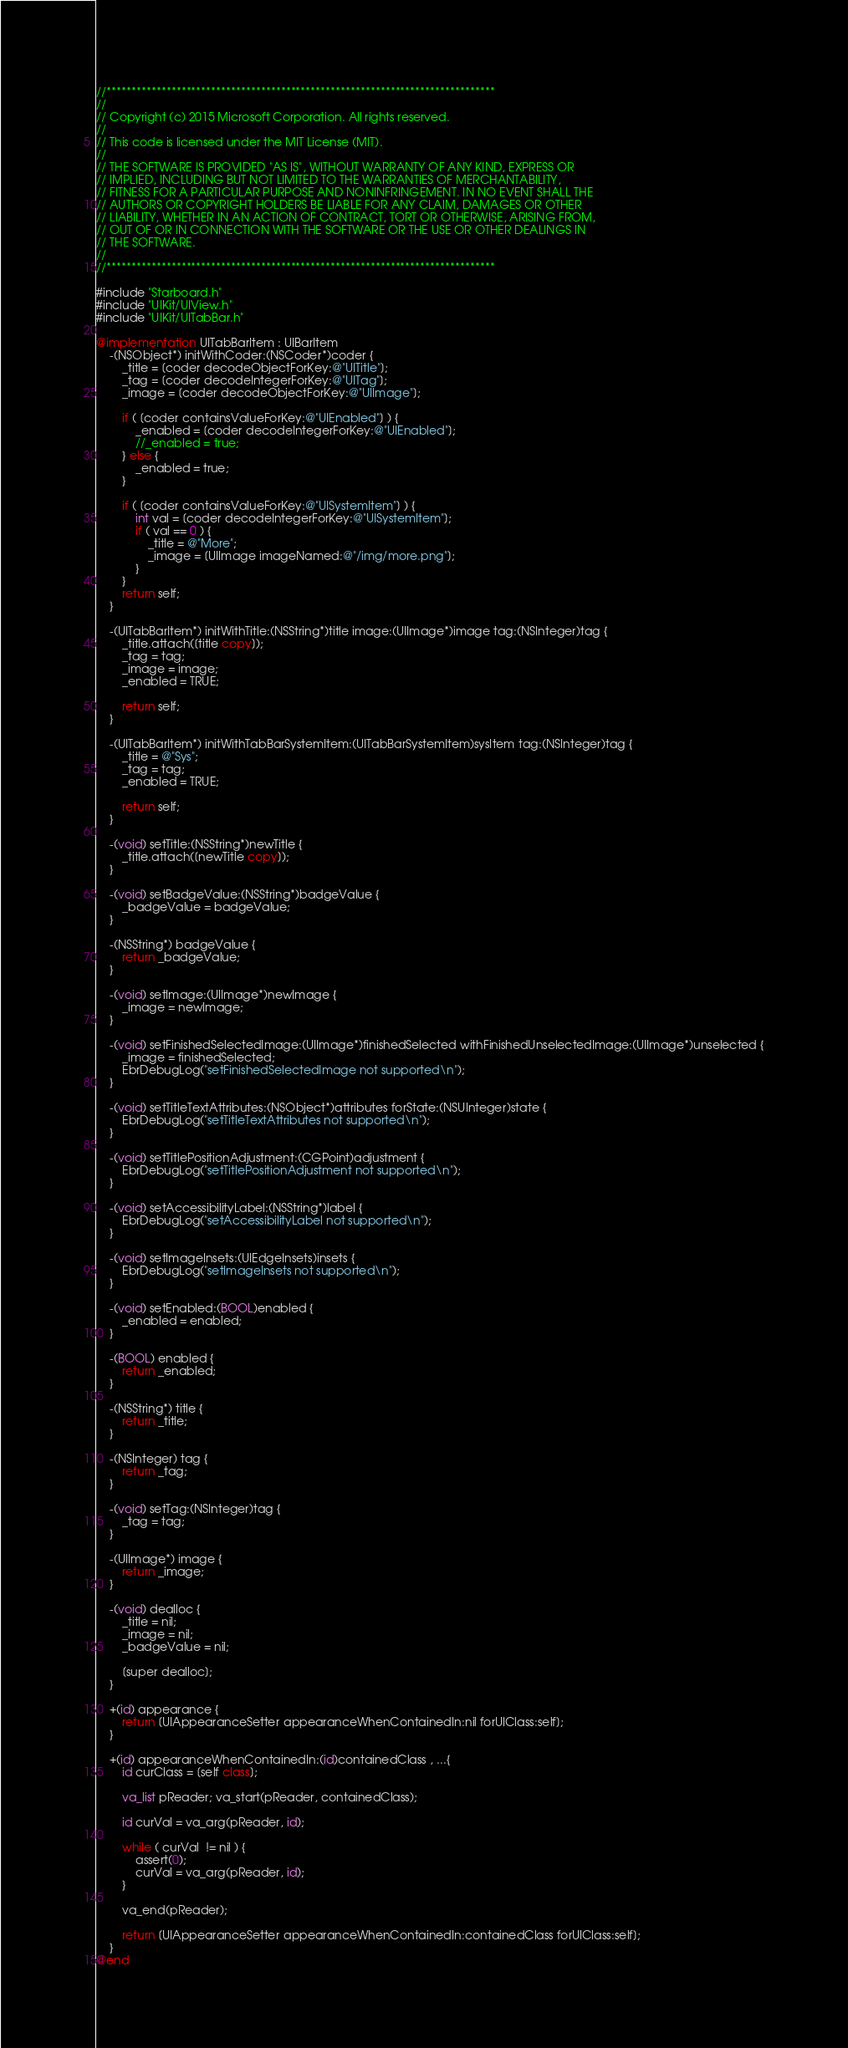<code> <loc_0><loc_0><loc_500><loc_500><_ObjectiveC_>//******************************************************************************
//
// Copyright (c) 2015 Microsoft Corporation. All rights reserved.
//
// This code is licensed under the MIT License (MIT).
//
// THE SOFTWARE IS PROVIDED "AS IS", WITHOUT WARRANTY OF ANY KIND, EXPRESS OR
// IMPLIED, INCLUDING BUT NOT LIMITED TO THE WARRANTIES OF MERCHANTABILITY,
// FITNESS FOR A PARTICULAR PURPOSE AND NONINFRINGEMENT. IN NO EVENT SHALL THE
// AUTHORS OR COPYRIGHT HOLDERS BE LIABLE FOR ANY CLAIM, DAMAGES OR OTHER
// LIABILITY, WHETHER IN AN ACTION OF CONTRACT, TORT OR OTHERWISE, ARISING FROM,
// OUT OF OR IN CONNECTION WITH THE SOFTWARE OR THE USE OR OTHER DEALINGS IN
// THE SOFTWARE.
//
//******************************************************************************

#include "Starboard.h"
#include "UIKit/UIView.h"
#include "UIKit/UITabBar.h"

@implementation UITabBarItem : UIBarItem
    -(NSObject*) initWithCoder:(NSCoder*)coder {
        _title = [coder decodeObjectForKey:@"UITitle"];
        _tag = [coder decodeIntegerForKey:@"UITag"];
        _image = [coder decodeObjectForKey:@"UIImage"];

        if ( [coder containsValueForKey:@"UIEnabled"] ) {
            _enabled = [coder decodeIntegerForKey:@"UIEnabled"];
            //_enabled = true;
        } else {
            _enabled = true;
        }

        if ( [coder containsValueForKey:@"UISystemItem"] ) {
            int val = [coder decodeIntegerForKey:@"UISystemItem"];
            if ( val == 0 ) {
                _title = @"More";
                _image = [UIImage imageNamed:@"/img/more.png"];
            }
        }
        return self;
    }

    -(UITabBarItem*) initWithTitle:(NSString*)title image:(UIImage*)image tag:(NSInteger)tag {
        _title.attach([title copy]);
        _tag = tag;
        _image = image;
        _enabled = TRUE;

        return self;
    }

    -(UITabBarItem*) initWithTabBarSystemItem:(UITabBarSystemItem)sysItem tag:(NSInteger)tag {
        _title = @"Sys";
        _tag = tag;
        _enabled = TRUE;

        return self;
    }

    -(void) setTitle:(NSString*)newTitle {
        _title.attach([newTitle copy]);
    }

    -(void) setBadgeValue:(NSString*)badgeValue {
        _badgeValue = badgeValue;
    }

    -(NSString*) badgeValue {
        return _badgeValue;
    }

    -(void) setImage:(UIImage*)newImage {
        _image = newImage;
    }

    -(void) setFinishedSelectedImage:(UIImage*)finishedSelected withFinishedUnselectedImage:(UIImage*)unselected {
        _image = finishedSelected;
        EbrDebugLog("setFinishedSelectedImage not supported\n");
    }

    -(void) setTitleTextAttributes:(NSObject*)attributes forState:(NSUInteger)state {
        EbrDebugLog("setTitleTextAttributes not supported\n");
    }

    -(void) setTitlePositionAdjustment:(CGPoint)adjustment {
        EbrDebugLog("setTitlePositionAdjustment not supported\n");
    }

    -(void) setAccessibilityLabel:(NSString*)label {
        EbrDebugLog("setAccessibilityLabel not supported\n");
    }

    -(void) setImageInsets:(UIEdgeInsets)insets {
        EbrDebugLog("setImageInsets not supported\n");
    }

    -(void) setEnabled:(BOOL)enabled {
        _enabled = enabled;
    }

    -(BOOL) enabled {
        return _enabled;
    }

    -(NSString*) title {
        return _title;
    }

    -(NSInteger) tag {
        return _tag;
    }

    -(void) setTag:(NSInteger)tag {
        _tag = tag;
    }

    -(UIImage*) image {
        return _image;
    }

    -(void) dealloc {
        _title = nil;
        _image = nil;
        _badgeValue = nil;

        [super dealloc];
    }

    +(id) appearance {
        return [UIAppearanceSetter appearanceWhenContainedIn:nil forUIClass:self];
    }

    +(id) appearanceWhenContainedIn:(id)containedClass , ...{
        id curClass = [self class];
    
        va_list pReader; va_start(pReader, containedClass);

        id curVal = va_arg(pReader, id);

        while ( curVal  != nil ) {
            assert(0);
            curVal = va_arg(pReader, id);
        }

        va_end(pReader);

        return [UIAppearanceSetter appearanceWhenContainedIn:containedClass forUIClass:self];
    }
@end

</code> 